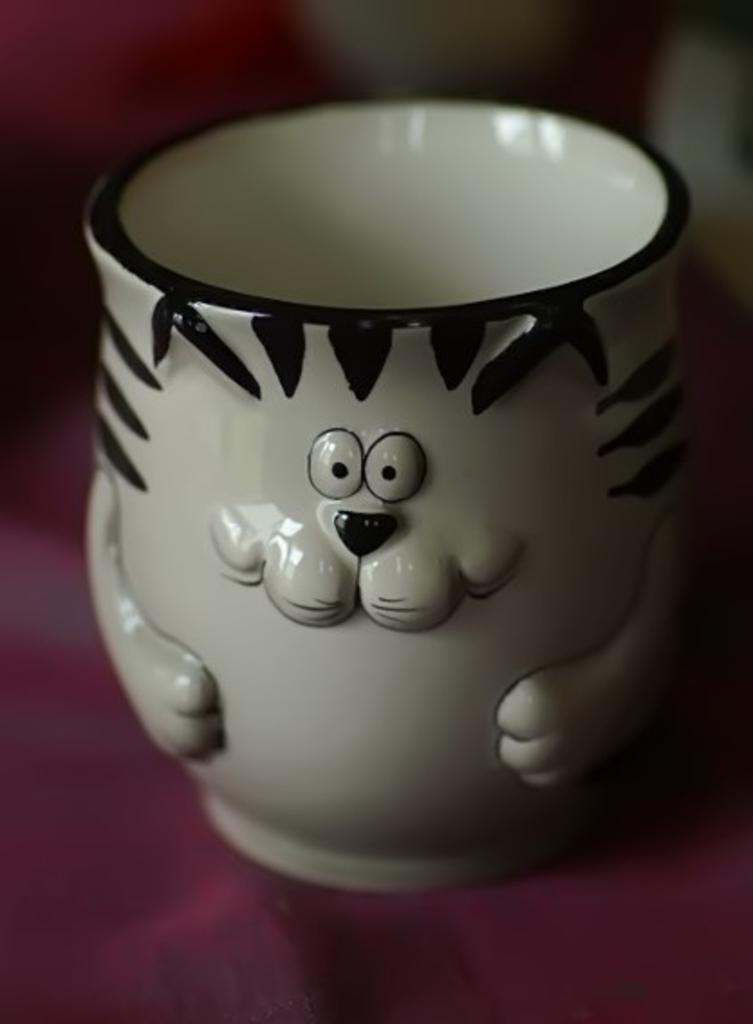What object is present in the image? There is a cup in the image. Can you describe the background of the image? The background of the image is blurry. How many horses are visible in the image? There are no horses present in the image; it only features a cup and a blurry background. What type of work does the fireman perform in the image? There is no fireman present in the image; it only features a cup and a blurry background. 